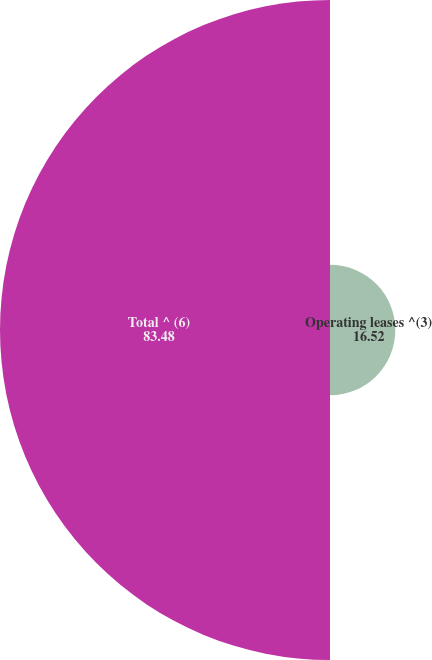<chart> <loc_0><loc_0><loc_500><loc_500><pie_chart><fcel>Operating leases ^(3)<fcel>Total ^ (6)<nl><fcel>16.52%<fcel>83.48%<nl></chart> 